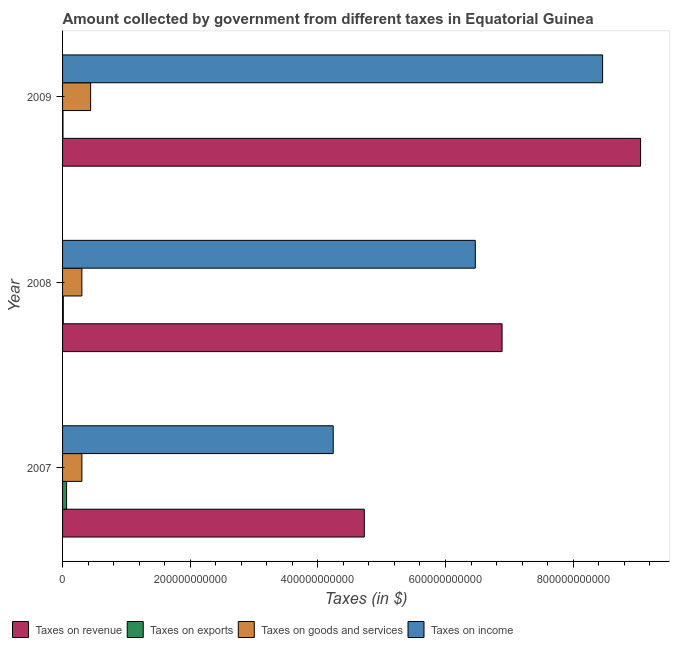In how many cases, is the number of bars for a given year not equal to the number of legend labels?
Ensure brevity in your answer.  0. What is the amount collected as tax on exports in 2007?
Offer a terse response. 6.32e+09. Across all years, what is the maximum amount collected as tax on revenue?
Give a very brief answer. 9.06e+11. Across all years, what is the minimum amount collected as tax on goods?
Provide a succinct answer. 3.03e+1. In which year was the amount collected as tax on goods maximum?
Your answer should be very brief. 2009. What is the total amount collected as tax on revenue in the graph?
Provide a succinct answer. 2.07e+12. What is the difference between the amount collected as tax on revenue in 2008 and that in 2009?
Offer a very short reply. -2.17e+11. What is the difference between the amount collected as tax on exports in 2009 and the amount collected as tax on goods in 2007?
Give a very brief answer. -2.96e+1. What is the average amount collected as tax on goods per year?
Offer a terse response. 3.48e+1. In the year 2007, what is the difference between the amount collected as tax on income and amount collected as tax on revenue?
Your answer should be very brief. -4.87e+1. In how many years, is the amount collected as tax on revenue greater than 480000000000 $?
Offer a terse response. 2. What is the ratio of the amount collected as tax on revenue in 2007 to that in 2008?
Make the answer very short. 0.69. Is the difference between the amount collected as tax on goods in 2008 and 2009 greater than the difference between the amount collected as tax on income in 2008 and 2009?
Provide a succinct answer. Yes. What is the difference between the highest and the second highest amount collected as tax on goods?
Your answer should be very brief. 1.37e+1. What is the difference between the highest and the lowest amount collected as tax on revenue?
Provide a short and direct response. 4.33e+11. In how many years, is the amount collected as tax on exports greater than the average amount collected as tax on exports taken over all years?
Offer a very short reply. 1. Is the sum of the amount collected as tax on revenue in 2007 and 2009 greater than the maximum amount collected as tax on goods across all years?
Make the answer very short. Yes. Is it the case that in every year, the sum of the amount collected as tax on income and amount collected as tax on exports is greater than the sum of amount collected as tax on revenue and amount collected as tax on goods?
Your answer should be compact. No. What does the 1st bar from the top in 2008 represents?
Your answer should be compact. Taxes on income. What does the 1st bar from the bottom in 2008 represents?
Provide a succinct answer. Taxes on revenue. Are all the bars in the graph horizontal?
Provide a succinct answer. Yes. How many years are there in the graph?
Make the answer very short. 3. What is the difference between two consecutive major ticks on the X-axis?
Your response must be concise. 2.00e+11. Does the graph contain grids?
Offer a very short reply. No. Where does the legend appear in the graph?
Offer a terse response. Bottom left. How are the legend labels stacked?
Provide a succinct answer. Horizontal. What is the title of the graph?
Your response must be concise. Amount collected by government from different taxes in Equatorial Guinea. Does "Other Minerals" appear as one of the legend labels in the graph?
Give a very brief answer. No. What is the label or title of the X-axis?
Provide a short and direct response. Taxes (in $). What is the label or title of the Y-axis?
Your answer should be compact. Year. What is the Taxes (in $) in Taxes on revenue in 2007?
Give a very brief answer. 4.73e+11. What is the Taxes (in $) in Taxes on exports in 2007?
Offer a very short reply. 6.32e+09. What is the Taxes (in $) of Taxes on goods and services in 2007?
Your response must be concise. 3.03e+1. What is the Taxes (in $) in Taxes on income in 2007?
Your answer should be very brief. 4.24e+11. What is the Taxes (in $) of Taxes on revenue in 2008?
Provide a short and direct response. 6.89e+11. What is the Taxes (in $) in Taxes on exports in 2008?
Provide a succinct answer. 1.14e+09. What is the Taxes (in $) in Taxes on goods and services in 2008?
Offer a very short reply. 3.03e+1. What is the Taxes (in $) in Taxes on income in 2008?
Give a very brief answer. 6.47e+11. What is the Taxes (in $) in Taxes on revenue in 2009?
Provide a short and direct response. 9.06e+11. What is the Taxes (in $) in Taxes on exports in 2009?
Your answer should be very brief. 6.58e+08. What is the Taxes (in $) in Taxes on goods and services in 2009?
Give a very brief answer. 4.40e+1. What is the Taxes (in $) in Taxes on income in 2009?
Provide a succinct answer. 8.46e+11. Across all years, what is the maximum Taxes (in $) of Taxes on revenue?
Provide a succinct answer. 9.06e+11. Across all years, what is the maximum Taxes (in $) in Taxes on exports?
Provide a succinct answer. 6.32e+09. Across all years, what is the maximum Taxes (in $) in Taxes on goods and services?
Provide a short and direct response. 4.40e+1. Across all years, what is the maximum Taxes (in $) of Taxes on income?
Provide a succinct answer. 8.46e+11. Across all years, what is the minimum Taxes (in $) in Taxes on revenue?
Give a very brief answer. 4.73e+11. Across all years, what is the minimum Taxes (in $) of Taxes on exports?
Your response must be concise. 6.58e+08. Across all years, what is the minimum Taxes (in $) in Taxes on goods and services?
Offer a terse response. 3.03e+1. Across all years, what is the minimum Taxes (in $) of Taxes on income?
Provide a short and direct response. 4.24e+11. What is the total Taxes (in $) in Taxes on revenue in the graph?
Give a very brief answer. 2.07e+12. What is the total Taxes (in $) of Taxes on exports in the graph?
Your response must be concise. 8.11e+09. What is the total Taxes (in $) in Taxes on goods and services in the graph?
Give a very brief answer. 1.05e+11. What is the total Taxes (in $) in Taxes on income in the graph?
Ensure brevity in your answer.  1.92e+12. What is the difference between the Taxes (in $) of Taxes on revenue in 2007 and that in 2008?
Provide a succinct answer. -2.16e+11. What is the difference between the Taxes (in $) of Taxes on exports in 2007 and that in 2008?
Offer a terse response. 5.17e+09. What is the difference between the Taxes (in $) of Taxes on goods and services in 2007 and that in 2008?
Provide a short and direct response. 1.60e+07. What is the difference between the Taxes (in $) in Taxes on income in 2007 and that in 2008?
Your response must be concise. -2.23e+11. What is the difference between the Taxes (in $) in Taxes on revenue in 2007 and that in 2009?
Ensure brevity in your answer.  -4.33e+11. What is the difference between the Taxes (in $) in Taxes on exports in 2007 and that in 2009?
Ensure brevity in your answer.  5.66e+09. What is the difference between the Taxes (in $) in Taxes on goods and services in 2007 and that in 2009?
Your answer should be very brief. -1.37e+1. What is the difference between the Taxes (in $) of Taxes on income in 2007 and that in 2009?
Your answer should be very brief. -4.22e+11. What is the difference between the Taxes (in $) in Taxes on revenue in 2008 and that in 2009?
Keep it short and to the point. -2.17e+11. What is the difference between the Taxes (in $) of Taxes on exports in 2008 and that in 2009?
Ensure brevity in your answer.  4.83e+08. What is the difference between the Taxes (in $) of Taxes on goods and services in 2008 and that in 2009?
Provide a succinct answer. -1.37e+1. What is the difference between the Taxes (in $) of Taxes on income in 2008 and that in 2009?
Ensure brevity in your answer.  -1.99e+11. What is the difference between the Taxes (in $) in Taxes on revenue in 2007 and the Taxes (in $) in Taxes on exports in 2008?
Ensure brevity in your answer.  4.72e+11. What is the difference between the Taxes (in $) of Taxes on revenue in 2007 and the Taxes (in $) of Taxes on goods and services in 2008?
Make the answer very short. 4.43e+11. What is the difference between the Taxes (in $) of Taxes on revenue in 2007 and the Taxes (in $) of Taxes on income in 2008?
Your answer should be very brief. -1.74e+11. What is the difference between the Taxes (in $) of Taxes on exports in 2007 and the Taxes (in $) of Taxes on goods and services in 2008?
Your response must be concise. -2.39e+1. What is the difference between the Taxes (in $) of Taxes on exports in 2007 and the Taxes (in $) of Taxes on income in 2008?
Offer a terse response. -6.40e+11. What is the difference between the Taxes (in $) in Taxes on goods and services in 2007 and the Taxes (in $) in Taxes on income in 2008?
Your answer should be compact. -6.16e+11. What is the difference between the Taxes (in $) of Taxes on revenue in 2007 and the Taxes (in $) of Taxes on exports in 2009?
Keep it short and to the point. 4.72e+11. What is the difference between the Taxes (in $) in Taxes on revenue in 2007 and the Taxes (in $) in Taxes on goods and services in 2009?
Make the answer very short. 4.29e+11. What is the difference between the Taxes (in $) in Taxes on revenue in 2007 and the Taxes (in $) in Taxes on income in 2009?
Make the answer very short. -3.73e+11. What is the difference between the Taxes (in $) of Taxes on exports in 2007 and the Taxes (in $) of Taxes on goods and services in 2009?
Keep it short and to the point. -3.77e+1. What is the difference between the Taxes (in $) in Taxes on exports in 2007 and the Taxes (in $) in Taxes on income in 2009?
Keep it short and to the point. -8.40e+11. What is the difference between the Taxes (in $) in Taxes on goods and services in 2007 and the Taxes (in $) in Taxes on income in 2009?
Provide a short and direct response. -8.16e+11. What is the difference between the Taxes (in $) in Taxes on revenue in 2008 and the Taxes (in $) in Taxes on exports in 2009?
Give a very brief answer. 6.88e+11. What is the difference between the Taxes (in $) of Taxes on revenue in 2008 and the Taxes (in $) of Taxes on goods and services in 2009?
Provide a short and direct response. 6.45e+11. What is the difference between the Taxes (in $) in Taxes on revenue in 2008 and the Taxes (in $) in Taxes on income in 2009?
Keep it short and to the point. -1.58e+11. What is the difference between the Taxes (in $) in Taxes on exports in 2008 and the Taxes (in $) in Taxes on goods and services in 2009?
Keep it short and to the point. -4.29e+1. What is the difference between the Taxes (in $) of Taxes on exports in 2008 and the Taxes (in $) of Taxes on income in 2009?
Your answer should be very brief. -8.45e+11. What is the difference between the Taxes (in $) of Taxes on goods and services in 2008 and the Taxes (in $) of Taxes on income in 2009?
Make the answer very short. -8.16e+11. What is the average Taxes (in $) of Taxes on revenue per year?
Offer a terse response. 6.89e+11. What is the average Taxes (in $) in Taxes on exports per year?
Keep it short and to the point. 2.70e+09. What is the average Taxes (in $) in Taxes on goods and services per year?
Provide a short and direct response. 3.48e+1. What is the average Taxes (in $) in Taxes on income per year?
Give a very brief answer. 6.39e+11. In the year 2007, what is the difference between the Taxes (in $) in Taxes on revenue and Taxes (in $) in Taxes on exports?
Your response must be concise. 4.66e+11. In the year 2007, what is the difference between the Taxes (in $) in Taxes on revenue and Taxes (in $) in Taxes on goods and services?
Your response must be concise. 4.43e+11. In the year 2007, what is the difference between the Taxes (in $) in Taxes on revenue and Taxes (in $) in Taxes on income?
Your response must be concise. 4.87e+1. In the year 2007, what is the difference between the Taxes (in $) of Taxes on exports and Taxes (in $) of Taxes on goods and services?
Offer a terse response. -2.40e+1. In the year 2007, what is the difference between the Taxes (in $) in Taxes on exports and Taxes (in $) in Taxes on income?
Offer a terse response. -4.18e+11. In the year 2007, what is the difference between the Taxes (in $) in Taxes on goods and services and Taxes (in $) in Taxes on income?
Ensure brevity in your answer.  -3.94e+11. In the year 2008, what is the difference between the Taxes (in $) in Taxes on revenue and Taxes (in $) in Taxes on exports?
Your answer should be very brief. 6.87e+11. In the year 2008, what is the difference between the Taxes (in $) of Taxes on revenue and Taxes (in $) of Taxes on goods and services?
Offer a very short reply. 6.58e+11. In the year 2008, what is the difference between the Taxes (in $) in Taxes on revenue and Taxes (in $) in Taxes on income?
Provide a succinct answer. 4.20e+1. In the year 2008, what is the difference between the Taxes (in $) in Taxes on exports and Taxes (in $) in Taxes on goods and services?
Your answer should be compact. -2.91e+1. In the year 2008, what is the difference between the Taxes (in $) in Taxes on exports and Taxes (in $) in Taxes on income?
Your response must be concise. -6.46e+11. In the year 2008, what is the difference between the Taxes (in $) of Taxes on goods and services and Taxes (in $) of Taxes on income?
Your answer should be very brief. -6.16e+11. In the year 2009, what is the difference between the Taxes (in $) in Taxes on revenue and Taxes (in $) in Taxes on exports?
Your response must be concise. 9.05e+11. In the year 2009, what is the difference between the Taxes (in $) in Taxes on revenue and Taxes (in $) in Taxes on goods and services?
Offer a very short reply. 8.62e+11. In the year 2009, what is the difference between the Taxes (in $) in Taxes on revenue and Taxes (in $) in Taxes on income?
Your answer should be compact. 5.95e+1. In the year 2009, what is the difference between the Taxes (in $) in Taxes on exports and Taxes (in $) in Taxes on goods and services?
Make the answer very short. -4.33e+1. In the year 2009, what is the difference between the Taxes (in $) of Taxes on exports and Taxes (in $) of Taxes on income?
Offer a very short reply. -8.45e+11. In the year 2009, what is the difference between the Taxes (in $) of Taxes on goods and services and Taxes (in $) of Taxes on income?
Your response must be concise. -8.02e+11. What is the ratio of the Taxes (in $) in Taxes on revenue in 2007 to that in 2008?
Provide a short and direct response. 0.69. What is the ratio of the Taxes (in $) in Taxes on exports in 2007 to that in 2008?
Your answer should be very brief. 5.53. What is the ratio of the Taxes (in $) in Taxes on goods and services in 2007 to that in 2008?
Keep it short and to the point. 1. What is the ratio of the Taxes (in $) of Taxes on income in 2007 to that in 2008?
Your answer should be compact. 0.66. What is the ratio of the Taxes (in $) of Taxes on revenue in 2007 to that in 2009?
Offer a very short reply. 0.52. What is the ratio of the Taxes (in $) of Taxes on exports in 2007 to that in 2009?
Your answer should be compact. 9.6. What is the ratio of the Taxes (in $) in Taxes on goods and services in 2007 to that in 2009?
Your answer should be very brief. 0.69. What is the ratio of the Taxes (in $) of Taxes on income in 2007 to that in 2009?
Provide a succinct answer. 0.5. What is the ratio of the Taxes (in $) of Taxes on revenue in 2008 to that in 2009?
Offer a terse response. 0.76. What is the ratio of the Taxes (in $) of Taxes on exports in 2008 to that in 2009?
Your answer should be very brief. 1.73. What is the ratio of the Taxes (in $) of Taxes on goods and services in 2008 to that in 2009?
Your answer should be very brief. 0.69. What is the ratio of the Taxes (in $) of Taxes on income in 2008 to that in 2009?
Provide a short and direct response. 0.76. What is the difference between the highest and the second highest Taxes (in $) of Taxes on revenue?
Provide a short and direct response. 2.17e+11. What is the difference between the highest and the second highest Taxes (in $) of Taxes on exports?
Keep it short and to the point. 5.17e+09. What is the difference between the highest and the second highest Taxes (in $) of Taxes on goods and services?
Offer a very short reply. 1.37e+1. What is the difference between the highest and the second highest Taxes (in $) in Taxes on income?
Your answer should be compact. 1.99e+11. What is the difference between the highest and the lowest Taxes (in $) in Taxes on revenue?
Give a very brief answer. 4.33e+11. What is the difference between the highest and the lowest Taxes (in $) of Taxes on exports?
Make the answer very short. 5.66e+09. What is the difference between the highest and the lowest Taxes (in $) of Taxes on goods and services?
Keep it short and to the point. 1.37e+1. What is the difference between the highest and the lowest Taxes (in $) of Taxes on income?
Your response must be concise. 4.22e+11. 